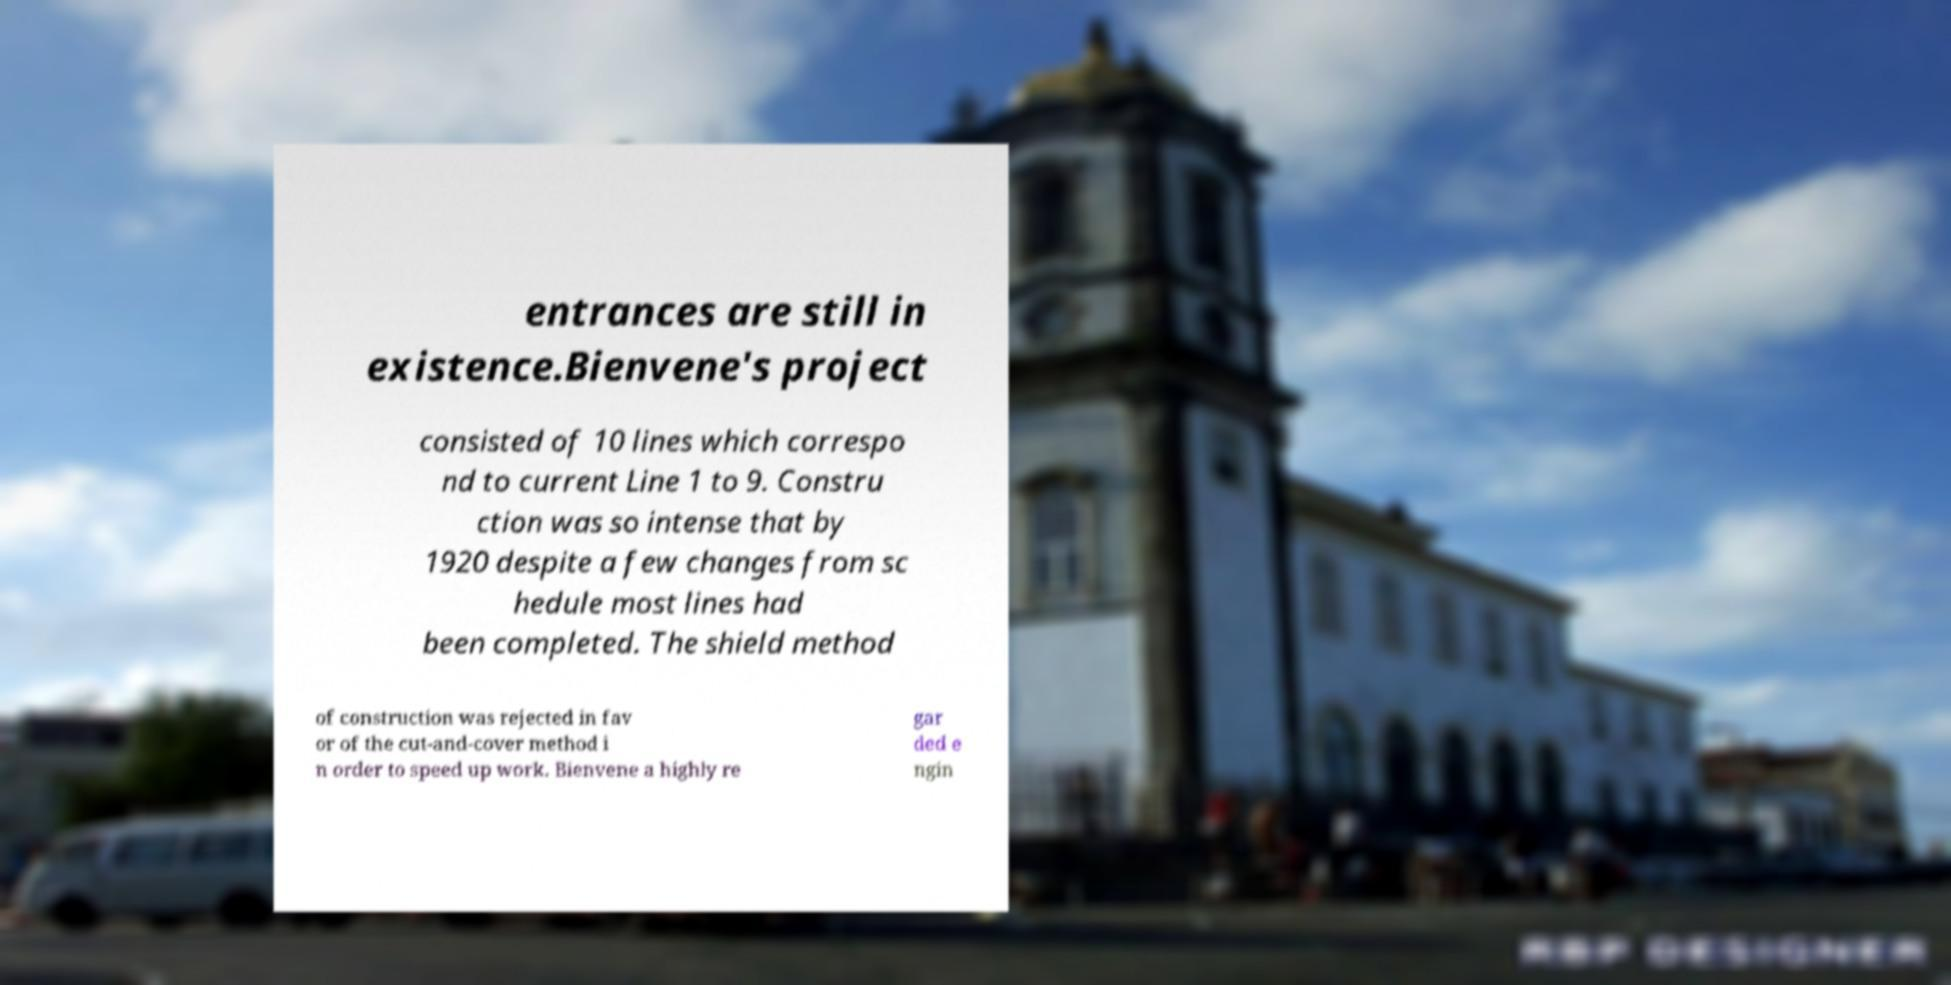Please read and relay the text visible in this image. What does it say? entrances are still in existence.Bienvene's project consisted of 10 lines which correspo nd to current Line 1 to 9. Constru ction was so intense that by 1920 despite a few changes from sc hedule most lines had been completed. The shield method of construction was rejected in fav or of the cut-and-cover method i n order to speed up work. Bienvene a highly re gar ded e ngin 